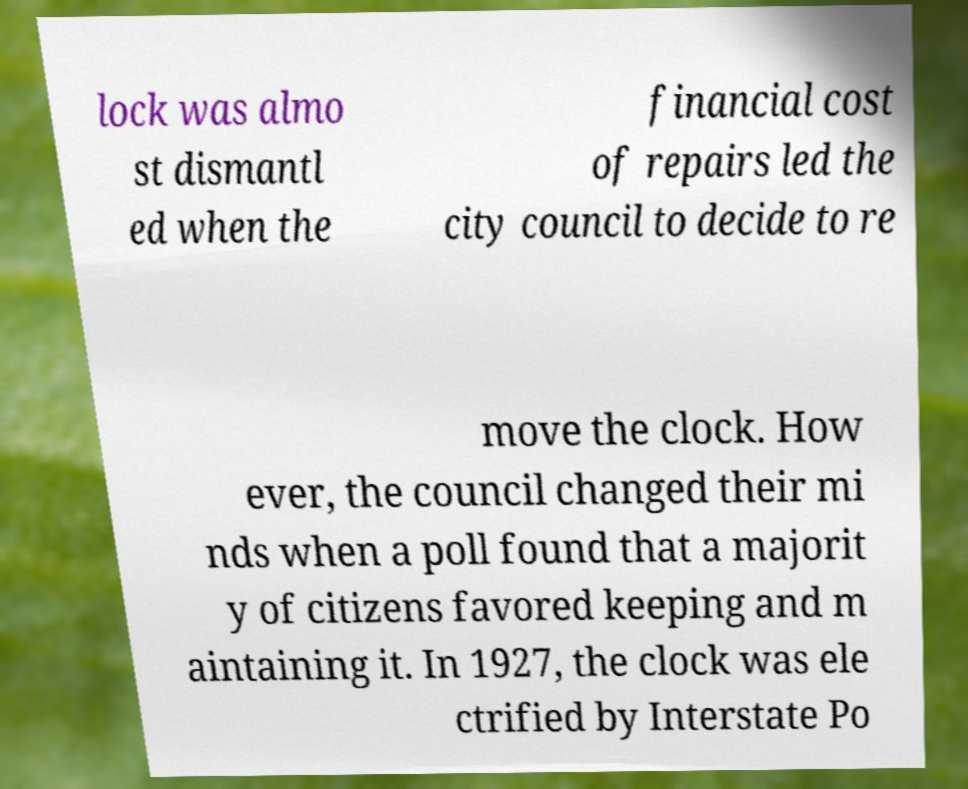What messages or text are displayed in this image? I need them in a readable, typed format. lock was almo st dismantl ed when the financial cost of repairs led the city council to decide to re move the clock. How ever, the council changed their mi nds when a poll found that a majorit y of citizens favored keeping and m aintaining it. In 1927, the clock was ele ctrified by Interstate Po 